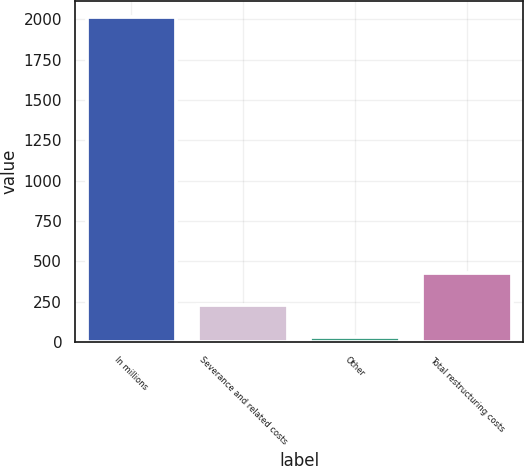Convert chart. <chart><loc_0><loc_0><loc_500><loc_500><bar_chart><fcel>In millions<fcel>Severance and related costs<fcel>Other<fcel>Total restructuring costs<nl><fcel>2014<fcel>227.86<fcel>29.4<fcel>426.32<nl></chart> 